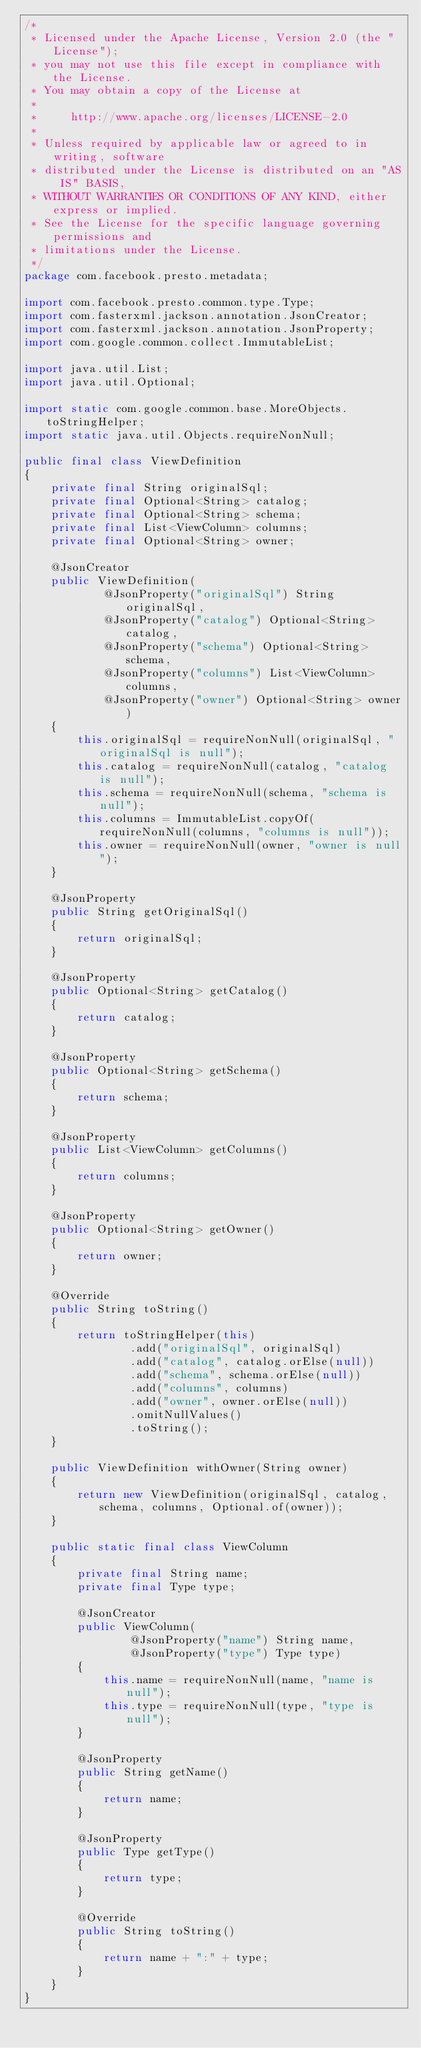Convert code to text. <code><loc_0><loc_0><loc_500><loc_500><_Java_>/*
 * Licensed under the Apache License, Version 2.0 (the "License");
 * you may not use this file except in compliance with the License.
 * You may obtain a copy of the License at
 *
 *     http://www.apache.org/licenses/LICENSE-2.0
 *
 * Unless required by applicable law or agreed to in writing, software
 * distributed under the License is distributed on an "AS IS" BASIS,
 * WITHOUT WARRANTIES OR CONDITIONS OF ANY KIND, either express or implied.
 * See the License for the specific language governing permissions and
 * limitations under the License.
 */
package com.facebook.presto.metadata;

import com.facebook.presto.common.type.Type;
import com.fasterxml.jackson.annotation.JsonCreator;
import com.fasterxml.jackson.annotation.JsonProperty;
import com.google.common.collect.ImmutableList;

import java.util.List;
import java.util.Optional;

import static com.google.common.base.MoreObjects.toStringHelper;
import static java.util.Objects.requireNonNull;

public final class ViewDefinition
{
    private final String originalSql;
    private final Optional<String> catalog;
    private final Optional<String> schema;
    private final List<ViewColumn> columns;
    private final Optional<String> owner;

    @JsonCreator
    public ViewDefinition(
            @JsonProperty("originalSql") String originalSql,
            @JsonProperty("catalog") Optional<String> catalog,
            @JsonProperty("schema") Optional<String> schema,
            @JsonProperty("columns") List<ViewColumn> columns,
            @JsonProperty("owner") Optional<String> owner)
    {
        this.originalSql = requireNonNull(originalSql, "originalSql is null");
        this.catalog = requireNonNull(catalog, "catalog is null");
        this.schema = requireNonNull(schema, "schema is null");
        this.columns = ImmutableList.copyOf(requireNonNull(columns, "columns is null"));
        this.owner = requireNonNull(owner, "owner is null");
    }

    @JsonProperty
    public String getOriginalSql()
    {
        return originalSql;
    }

    @JsonProperty
    public Optional<String> getCatalog()
    {
        return catalog;
    }

    @JsonProperty
    public Optional<String> getSchema()
    {
        return schema;
    }

    @JsonProperty
    public List<ViewColumn> getColumns()
    {
        return columns;
    }

    @JsonProperty
    public Optional<String> getOwner()
    {
        return owner;
    }

    @Override
    public String toString()
    {
        return toStringHelper(this)
                .add("originalSql", originalSql)
                .add("catalog", catalog.orElse(null))
                .add("schema", schema.orElse(null))
                .add("columns", columns)
                .add("owner", owner.orElse(null))
                .omitNullValues()
                .toString();
    }

    public ViewDefinition withOwner(String owner)
    {
        return new ViewDefinition(originalSql, catalog, schema, columns, Optional.of(owner));
    }

    public static final class ViewColumn
    {
        private final String name;
        private final Type type;

        @JsonCreator
        public ViewColumn(
                @JsonProperty("name") String name,
                @JsonProperty("type") Type type)
        {
            this.name = requireNonNull(name, "name is null");
            this.type = requireNonNull(type, "type is null");
        }

        @JsonProperty
        public String getName()
        {
            return name;
        }

        @JsonProperty
        public Type getType()
        {
            return type;
        }

        @Override
        public String toString()
        {
            return name + ":" + type;
        }
    }
}
</code> 